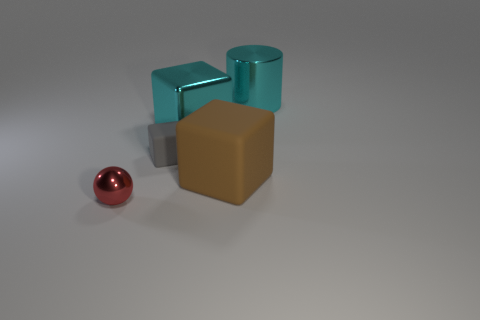Subtract all matte cubes. How many cubes are left? 1 Add 1 tiny blue shiny spheres. How many objects exist? 6 Subtract all purple blocks. Subtract all red cylinders. How many blocks are left? 3 Subtract all cylinders. How many objects are left? 4 Add 2 tiny purple rubber cylinders. How many tiny purple rubber cylinders exist? 2 Subtract 0 gray cylinders. How many objects are left? 5 Subtract all large brown matte cubes. Subtract all small red metal things. How many objects are left? 3 Add 5 big brown matte objects. How many big brown matte objects are left? 6 